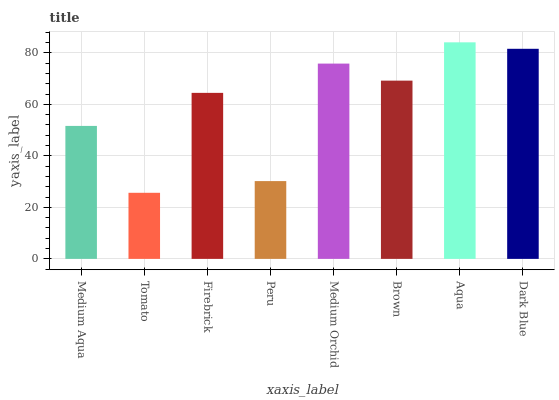Is Tomato the minimum?
Answer yes or no. Yes. Is Aqua the maximum?
Answer yes or no. Yes. Is Firebrick the minimum?
Answer yes or no. No. Is Firebrick the maximum?
Answer yes or no. No. Is Firebrick greater than Tomato?
Answer yes or no. Yes. Is Tomato less than Firebrick?
Answer yes or no. Yes. Is Tomato greater than Firebrick?
Answer yes or no. No. Is Firebrick less than Tomato?
Answer yes or no. No. Is Brown the high median?
Answer yes or no. Yes. Is Firebrick the low median?
Answer yes or no. Yes. Is Dark Blue the high median?
Answer yes or no. No. Is Medium Aqua the low median?
Answer yes or no. No. 